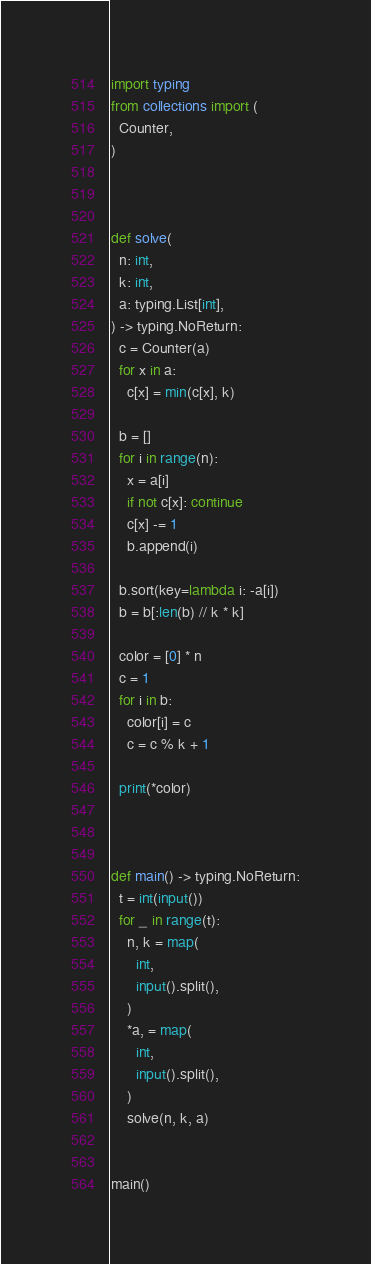<code> <loc_0><loc_0><loc_500><loc_500><_Python_>import typing 
from collections import (
  Counter,
)



def solve(
  n: int,
  k: int,
  a: typing.List[int],
) -> typing.NoReturn:
  c = Counter(a)
  for x in a:
    c[x] = min(c[x], k)
  
  b = []
  for i in range(n):
    x = a[i]
    if not c[x]: continue
    c[x] -= 1
    b.append(i)
  
  b.sort(key=lambda i: -a[i])
  b = b[:len(b) // k * k]

  color = [0] * n
  c = 1
  for i in b:
    color[i] = c 
    c = c % k + 1
  
  print(*color)
  


def main() -> typing.NoReturn:
  t = int(input())
  for _ in range(t):
    n, k = map(
      int,
      input().split(),
    )
    *a, = map(
      int,
      input().split(),
    )
    solve(n, k, a)


main()</code> 